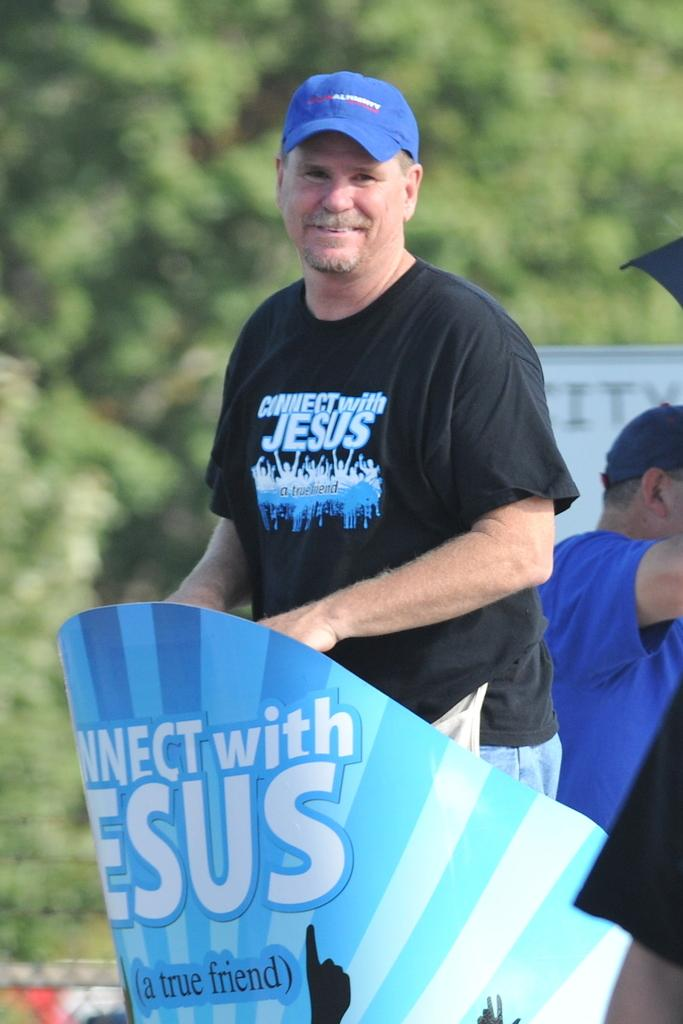What is the expression of the person in the front of the image? The person in the front of the image has a smiling face. Can you describe the positioning of the two people in the image? There is a person standing in front, and another person is standing behind them. What can be seen in the background of the image? There are trees in the background of the image. What type of grape is being used as a prop in the image? There is no grape present in the image. 